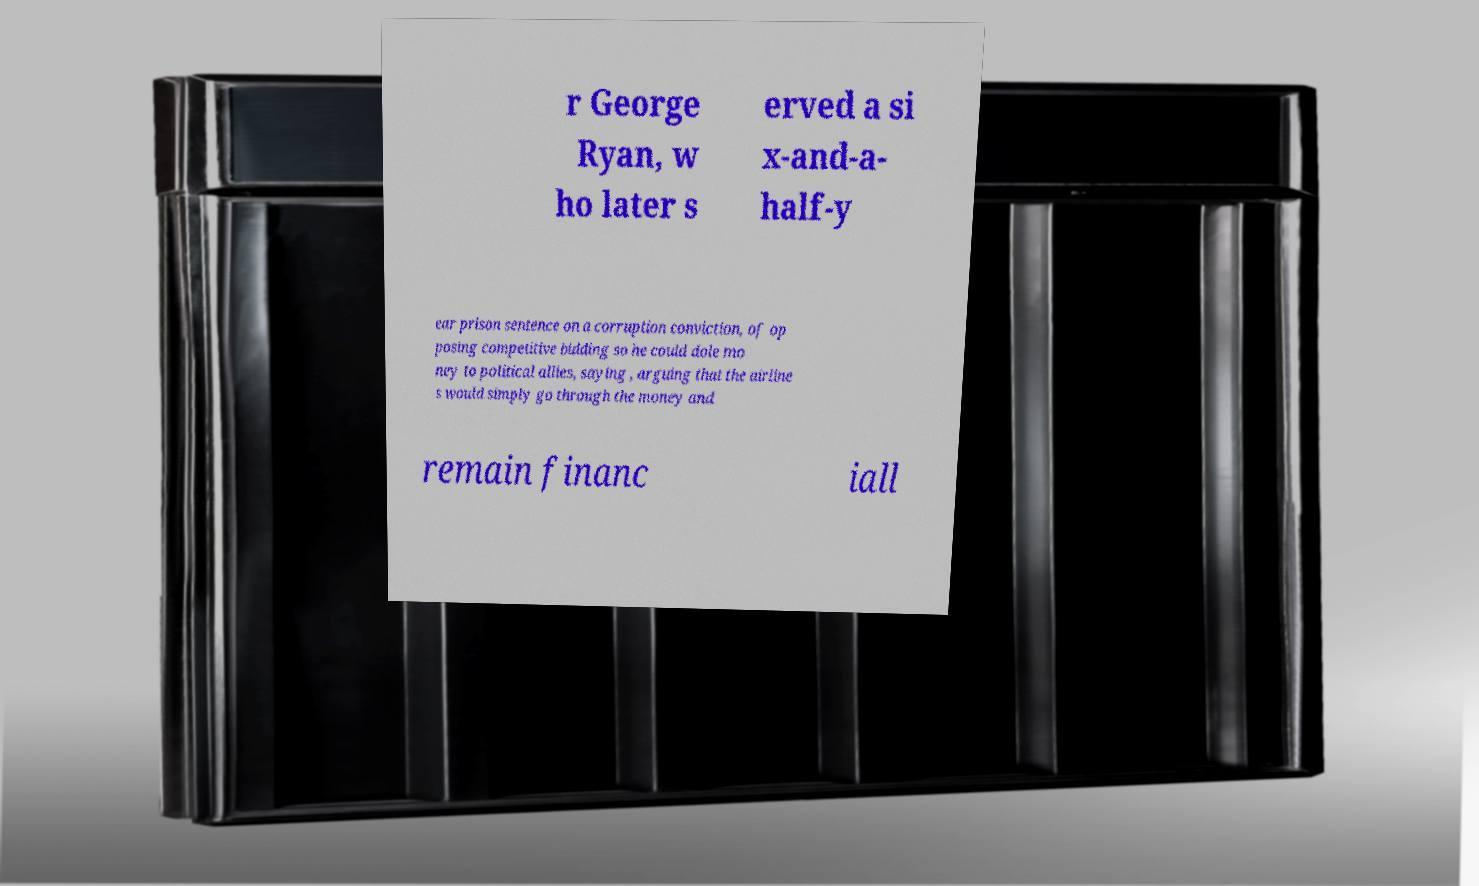Could you assist in decoding the text presented in this image and type it out clearly? r George Ryan, w ho later s erved a si x-and-a- half-y ear prison sentence on a corruption conviction, of op posing competitive bidding so he could dole mo ney to political allies, saying , arguing that the airline s would simply go through the money and remain financ iall 